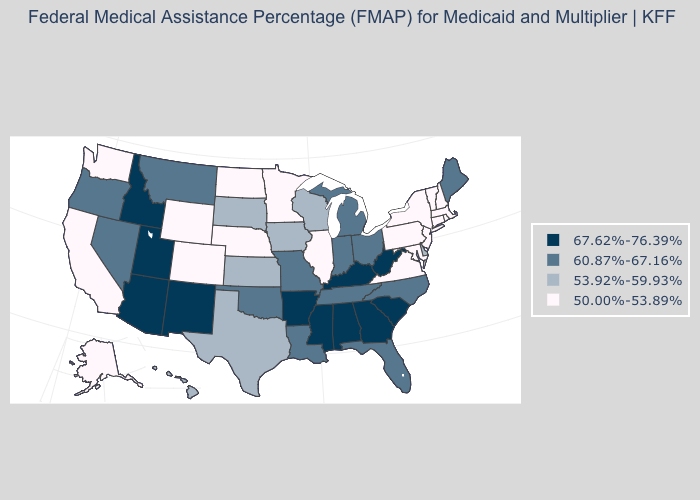What is the lowest value in the South?
Give a very brief answer. 50.00%-53.89%. Name the states that have a value in the range 50.00%-53.89%?
Quick response, please. Alaska, California, Colorado, Connecticut, Illinois, Maryland, Massachusetts, Minnesota, Nebraska, New Hampshire, New Jersey, New York, North Dakota, Pennsylvania, Rhode Island, Vermont, Virginia, Washington, Wyoming. What is the value of Rhode Island?
Short answer required. 50.00%-53.89%. Does Utah have the highest value in the USA?
Concise answer only. Yes. Name the states that have a value in the range 67.62%-76.39%?
Keep it brief. Alabama, Arizona, Arkansas, Georgia, Idaho, Kentucky, Mississippi, New Mexico, South Carolina, Utah, West Virginia. What is the value of Michigan?
Quick response, please. 60.87%-67.16%. Does Delaware have the lowest value in the South?
Answer briefly. No. Which states hav the highest value in the West?
Quick response, please. Arizona, Idaho, New Mexico, Utah. Among the states that border Connecticut , which have the highest value?
Write a very short answer. Massachusetts, New York, Rhode Island. Name the states that have a value in the range 50.00%-53.89%?
Keep it brief. Alaska, California, Colorado, Connecticut, Illinois, Maryland, Massachusetts, Minnesota, Nebraska, New Hampshire, New Jersey, New York, North Dakota, Pennsylvania, Rhode Island, Vermont, Virginia, Washington, Wyoming. What is the value of Washington?
Concise answer only. 50.00%-53.89%. What is the value of Michigan?
Keep it brief. 60.87%-67.16%. Name the states that have a value in the range 53.92%-59.93%?
Give a very brief answer. Delaware, Hawaii, Iowa, Kansas, South Dakota, Texas, Wisconsin. What is the lowest value in the MidWest?
Be succinct. 50.00%-53.89%. Name the states that have a value in the range 67.62%-76.39%?
Quick response, please. Alabama, Arizona, Arkansas, Georgia, Idaho, Kentucky, Mississippi, New Mexico, South Carolina, Utah, West Virginia. 